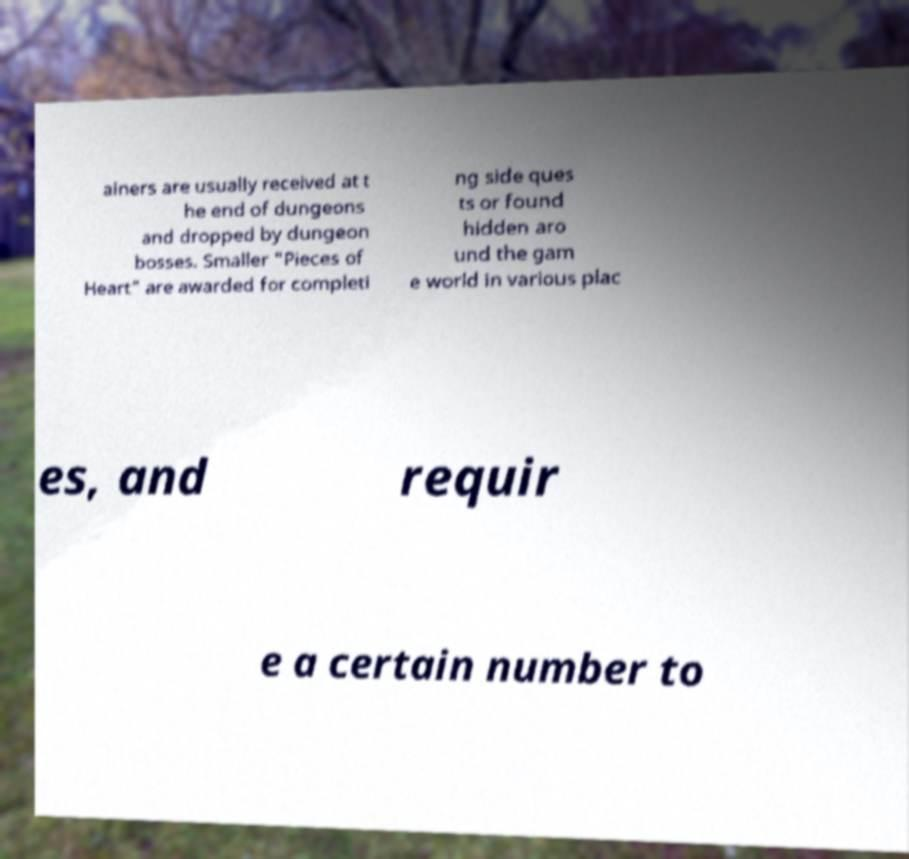I need the written content from this picture converted into text. Can you do that? ainers are usually received at t he end of dungeons and dropped by dungeon bosses. Smaller "Pieces of Heart" are awarded for completi ng side ques ts or found hidden aro und the gam e world in various plac es, and requir e a certain number to 